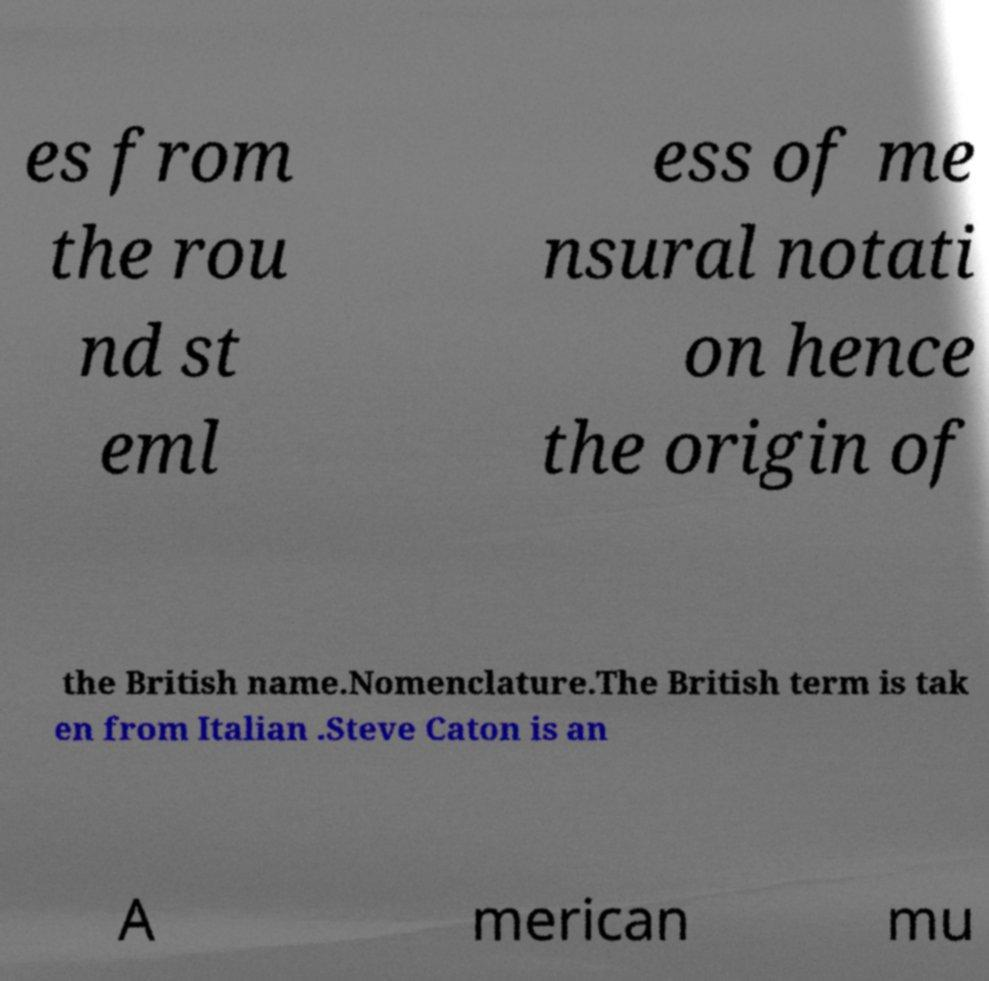Please read and relay the text visible in this image. What does it say? es from the rou nd st eml ess of me nsural notati on hence the origin of the British name.Nomenclature.The British term is tak en from Italian .Steve Caton is an A merican mu 